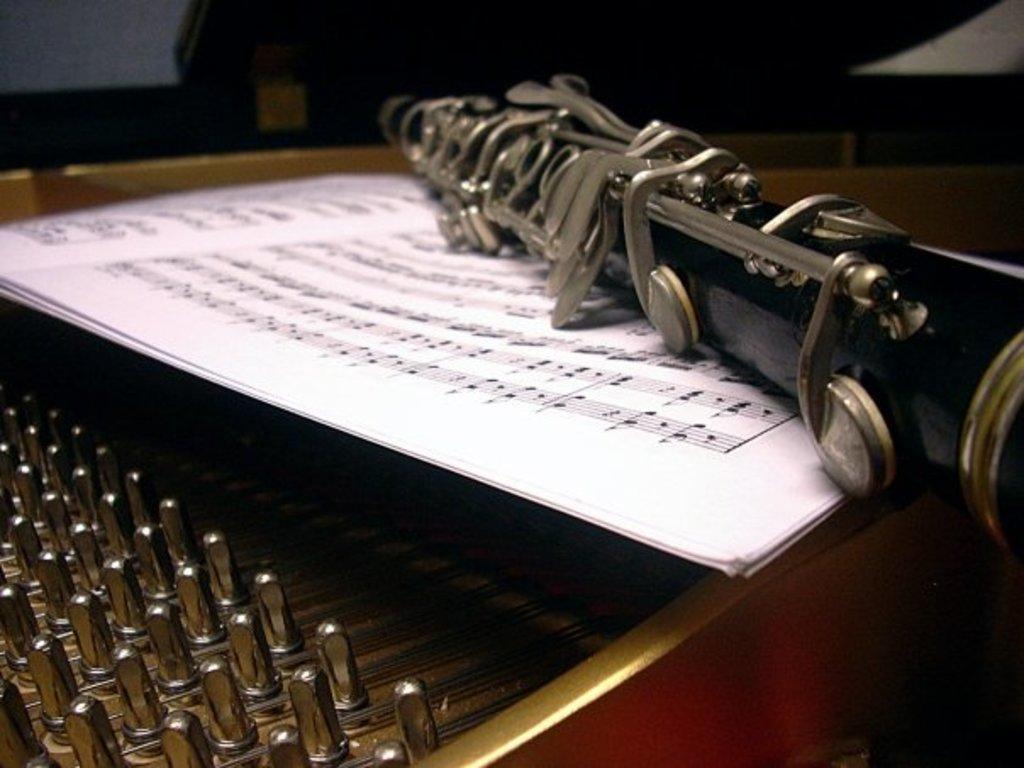Please provide a concise description of this image. In this image I can see two musical instruments which are in black, silver and red color. I can also see some white color papers on the instrument. 